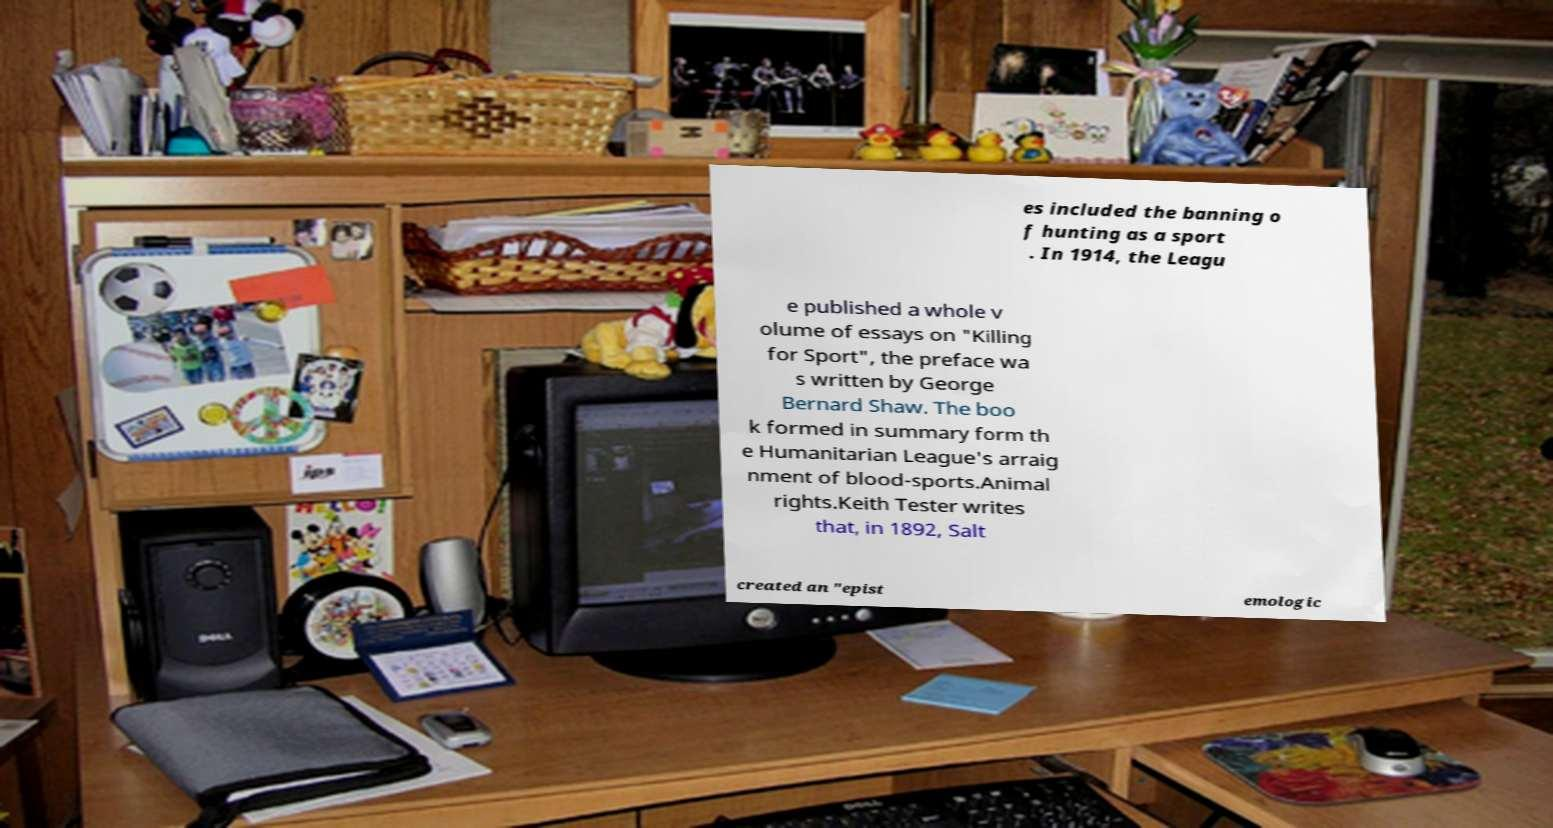For documentation purposes, I need the text within this image transcribed. Could you provide that? es included the banning o f hunting as a sport . In 1914, the Leagu e published a whole v olume of essays on "Killing for Sport", the preface wa s written by George Bernard Shaw. The boo k formed in summary form th e Humanitarian League's arraig nment of blood-sports.Animal rights.Keith Tester writes that, in 1892, Salt created an "epist emologic 